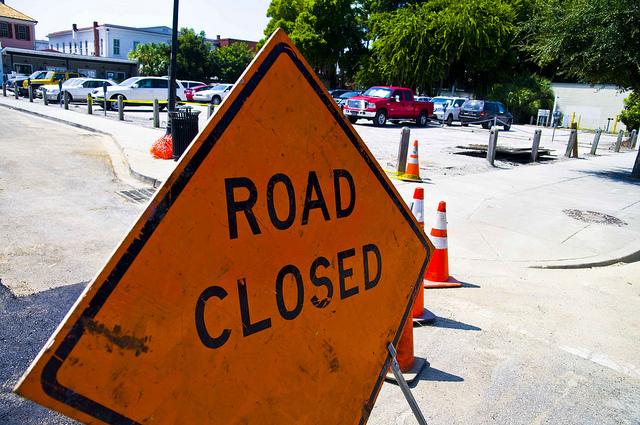Do you think we should drive on this road?
Quick response, please. No. What does the orange sign read?
Quick response, please. Road closed. Are there construction workers on the road?
Quick response, please. No. 